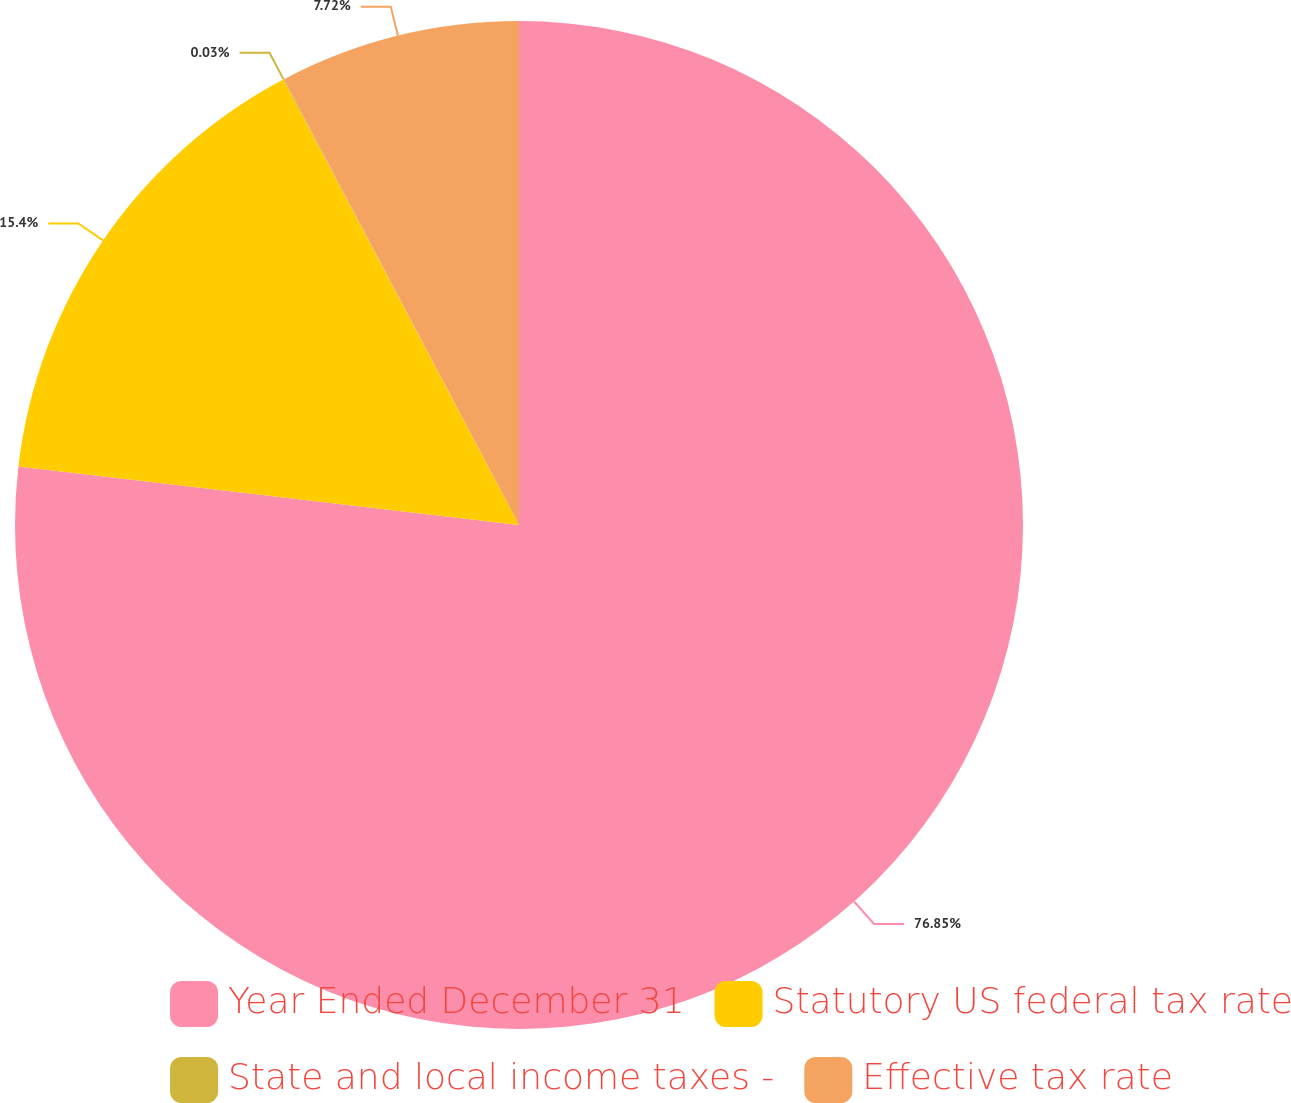<chart> <loc_0><loc_0><loc_500><loc_500><pie_chart><fcel>Year Ended December 31<fcel>Statutory US federal tax rate<fcel>State and local income taxes -<fcel>Effective tax rate<nl><fcel>76.85%<fcel>15.4%<fcel>0.03%<fcel>7.72%<nl></chart> 